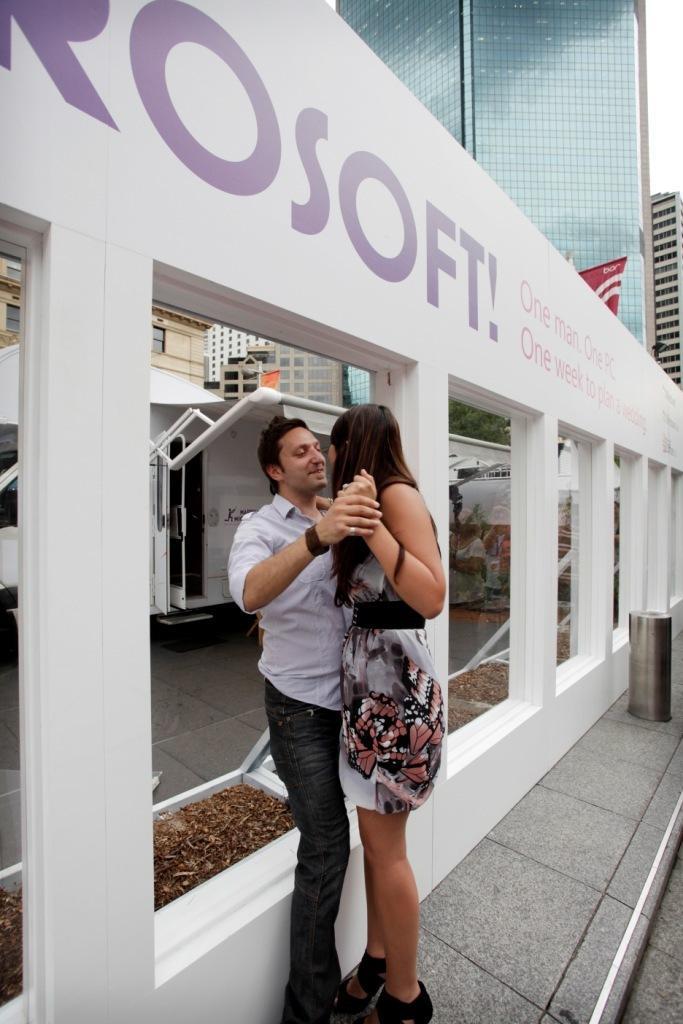Could you give a brief overview of what you see in this image? In this picture I can see a man and woman standing holding hands together. I can see the buildings in the background. 